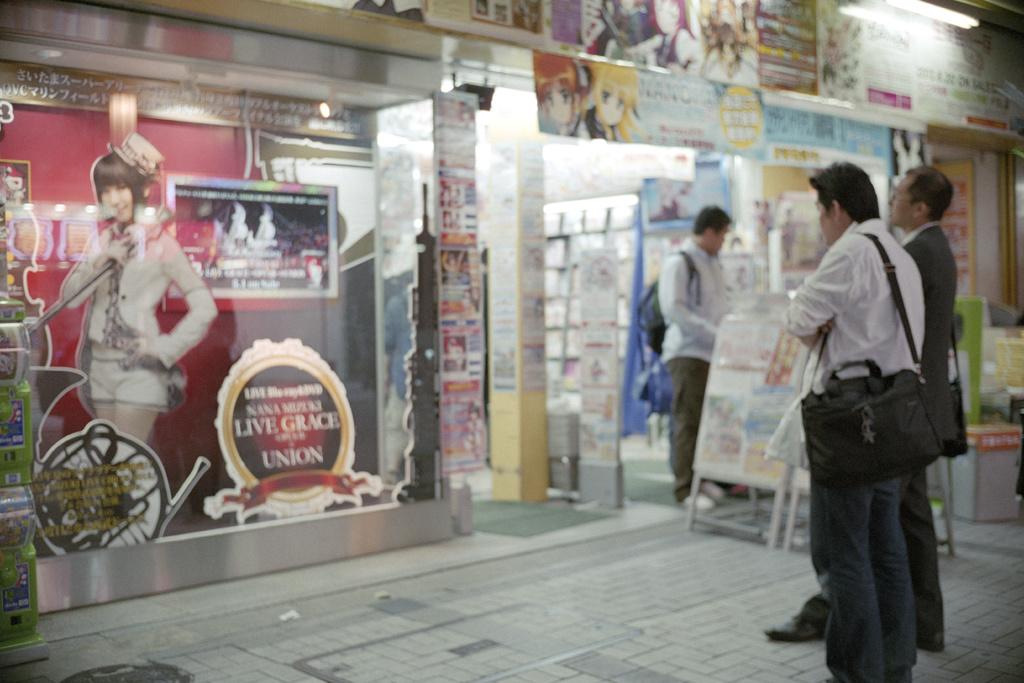What does the sign tell you to do with grace?
Your answer should be very brief. Live. 